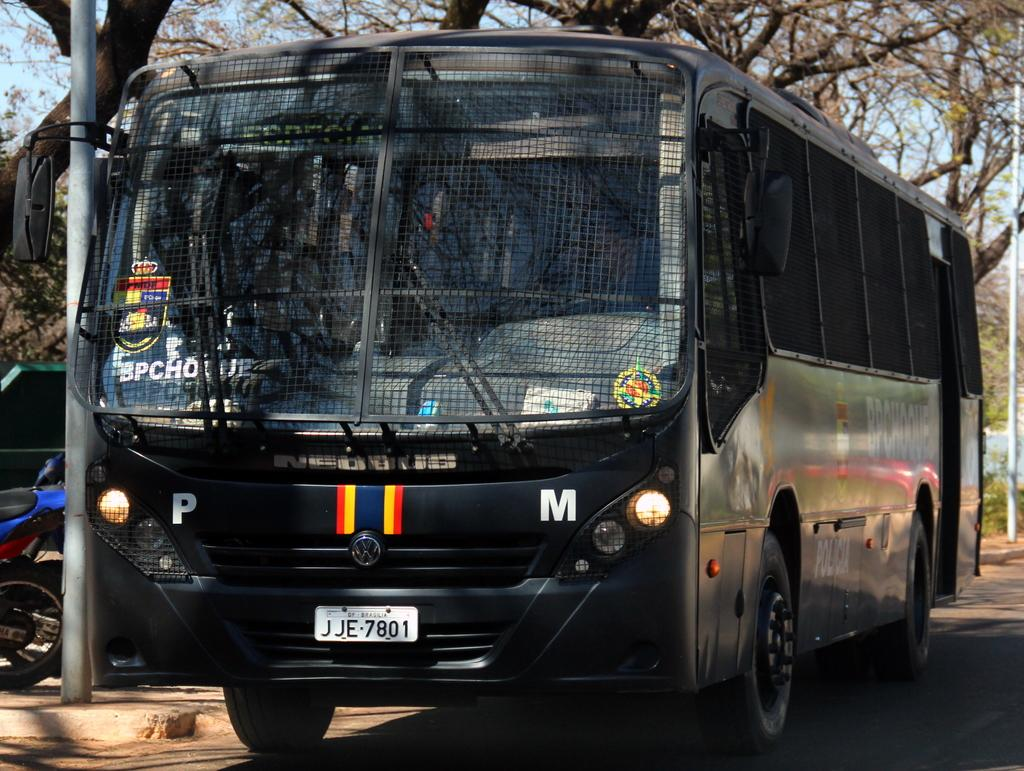Where was the picture taken? The picture was taken outside. What can be seen in the center of the image? There are vehicles in the center of the image. How are the vehicles positioned in the image? The vehicles are parked on the ground. What can be seen in the background of the image? There is sky, trees, poles, and other items visible in the background of the image. What type of yam is being harvested in the image? There is no yam present in the image; it features vehicles parked outside with a background of sky, trees, and poles. What kind of paper is being used to write on in the image? There is no paper visible in the image; it only shows vehicles parked outside with a background of sky, trees, and poles. 